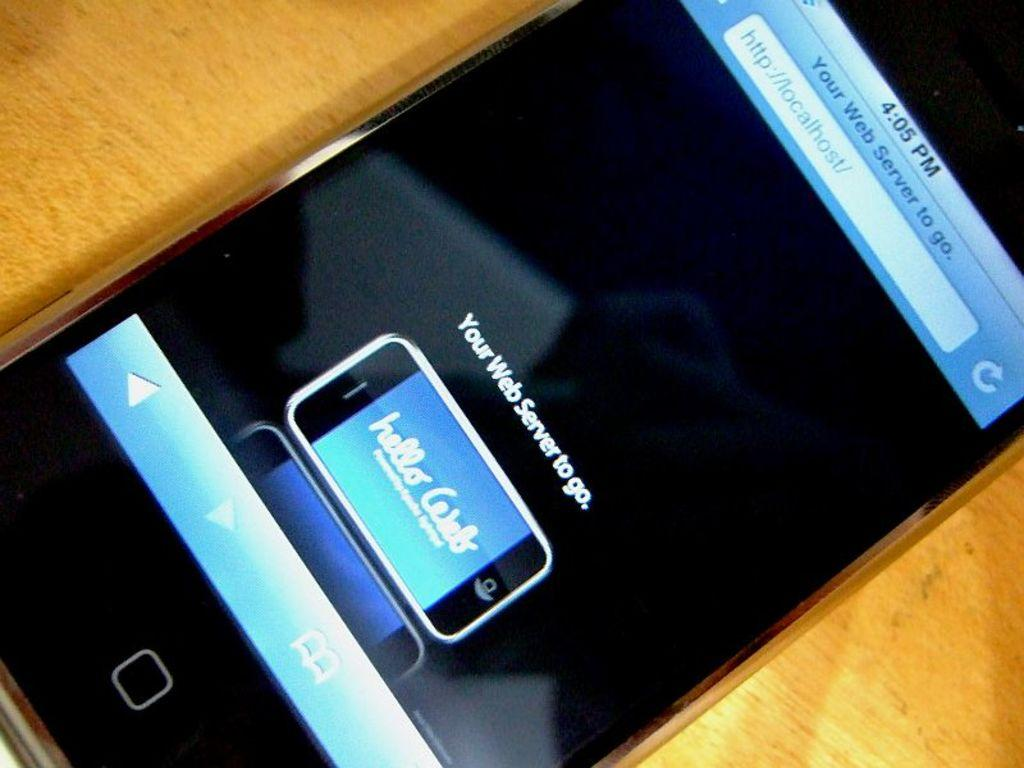<image>
Provide a brief description of the given image. A phone with a notification that says your web server to go on it. 